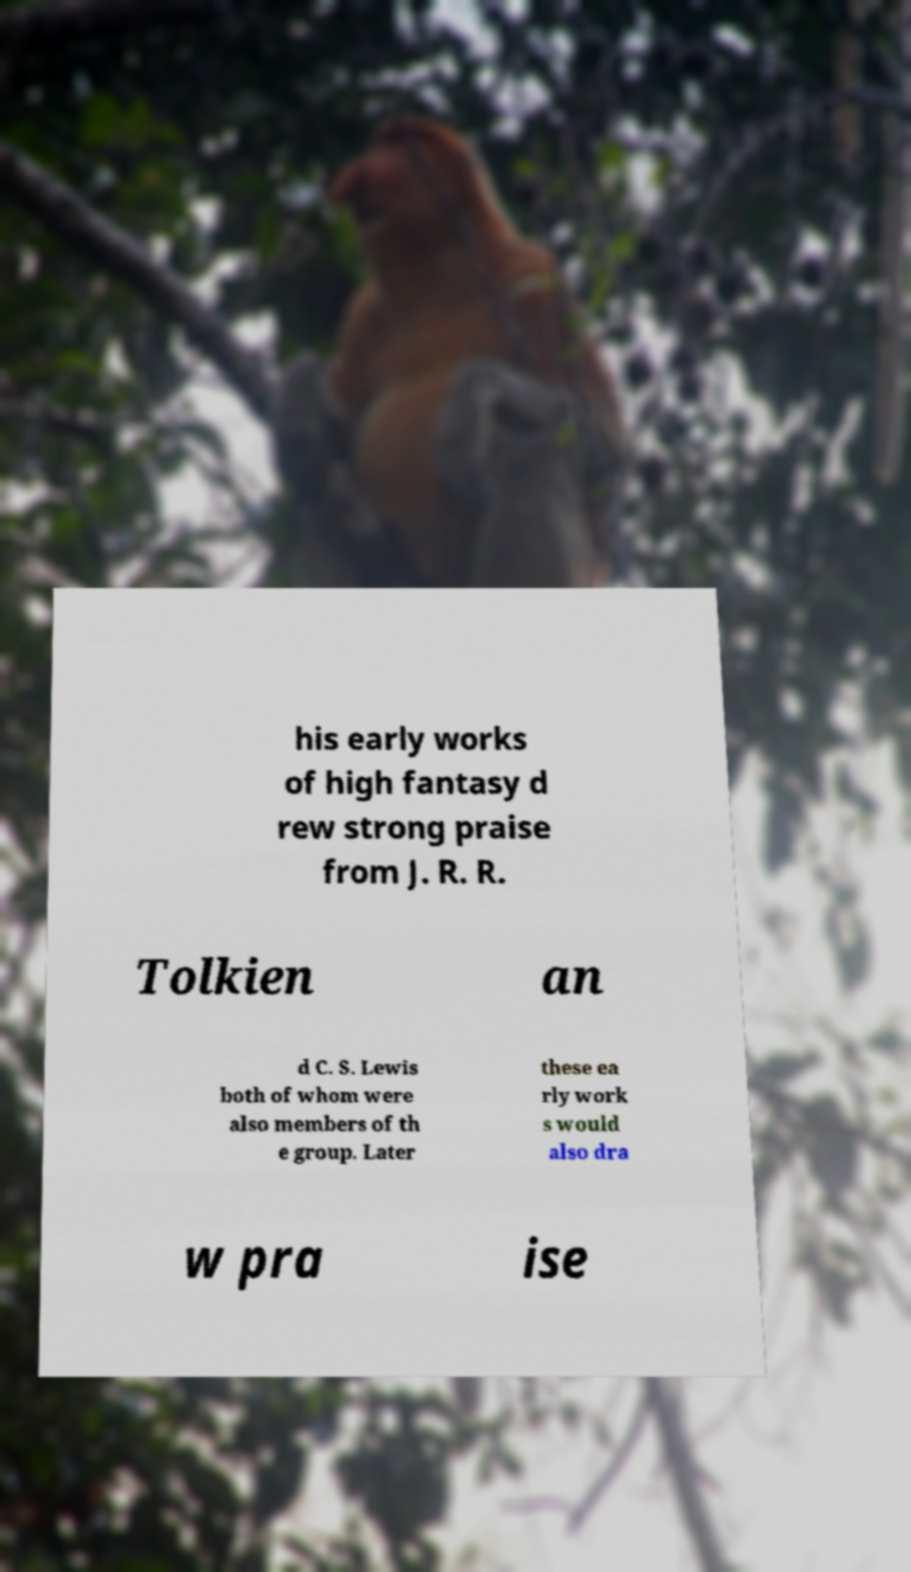Please identify and transcribe the text found in this image. his early works of high fantasy d rew strong praise from J. R. R. Tolkien an d C. S. Lewis both of whom were also members of th e group. Later these ea rly work s would also dra w pra ise 